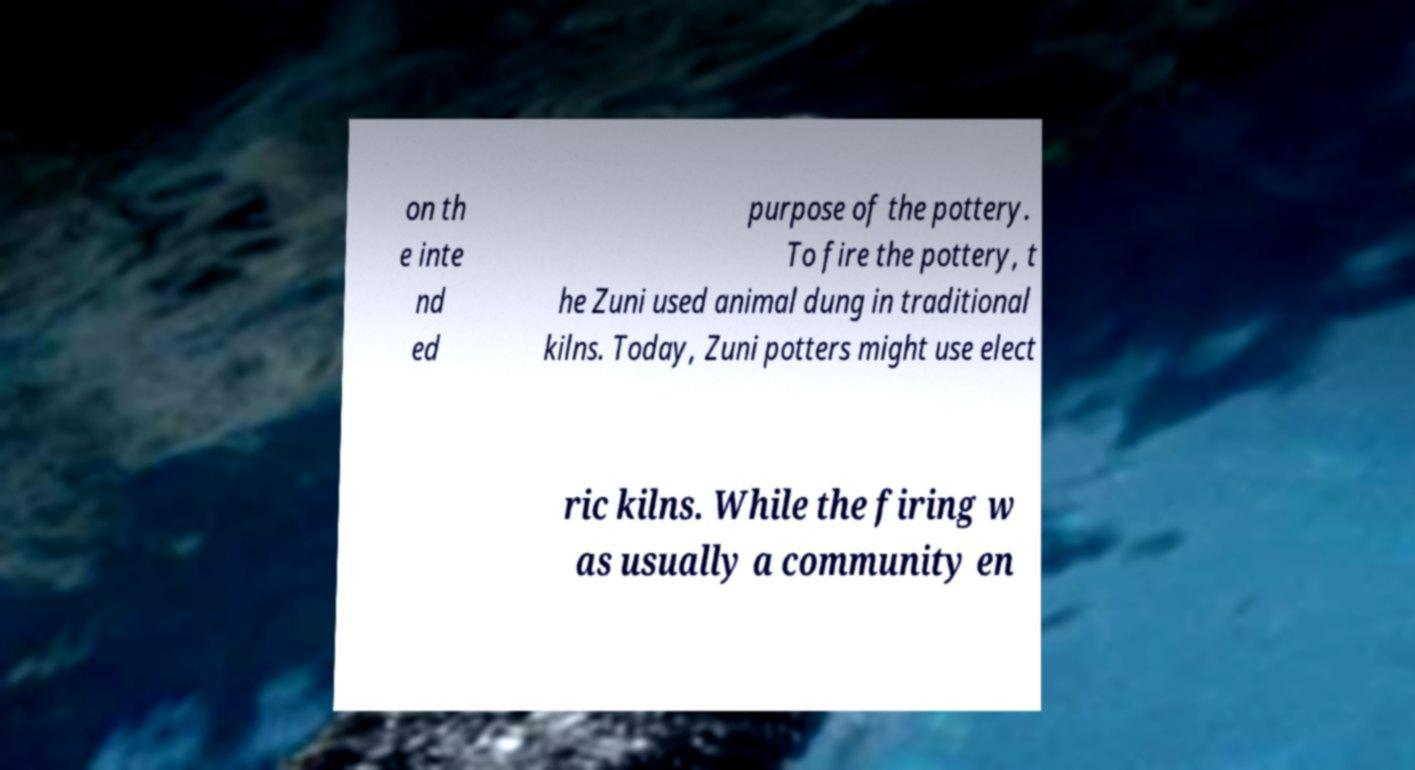For documentation purposes, I need the text within this image transcribed. Could you provide that? on th e inte nd ed purpose of the pottery. To fire the pottery, t he Zuni used animal dung in traditional kilns. Today, Zuni potters might use elect ric kilns. While the firing w as usually a community en 